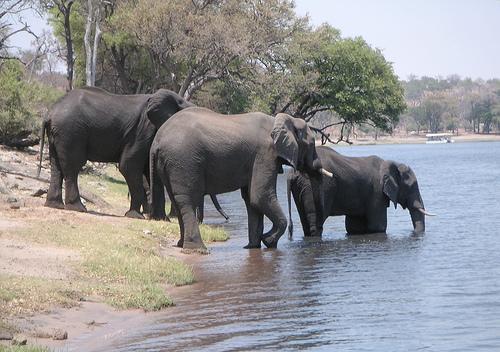How many elephants are there?
Give a very brief answer. 3. 